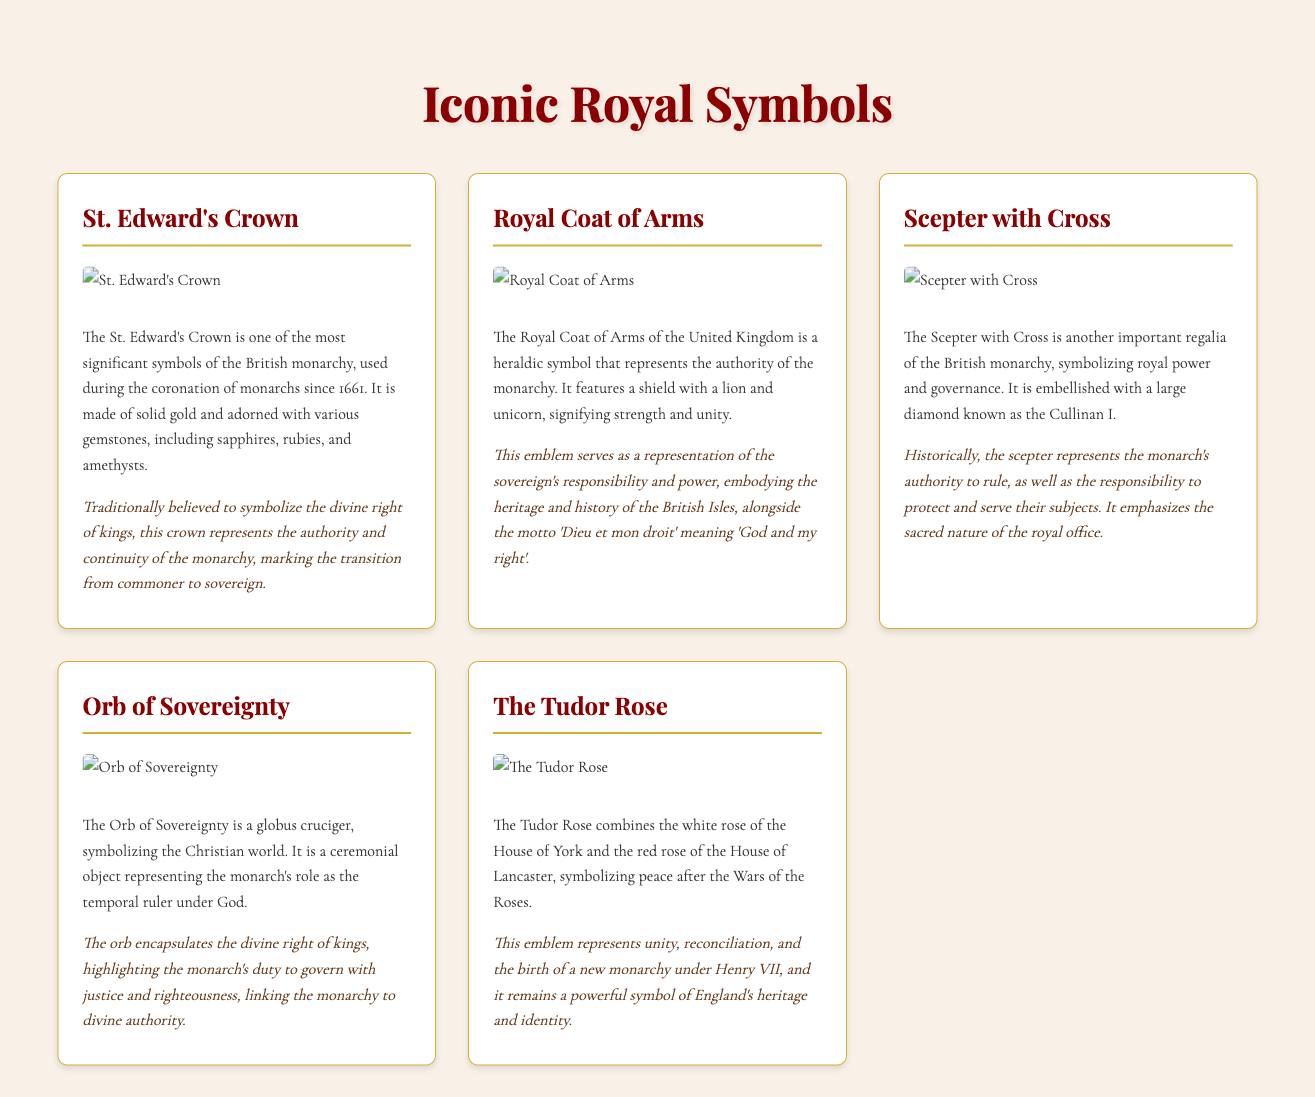What crown is used during the coronation of monarchs since 1661? The document states that the St. Edward's Crown is used during the coronation of monarchs since 1661.
Answer: St. Edward's Crown What animal is featured in the Royal Coat of Arms alongside a unicorn? The Royal Coat of Arms features a lion alongside a unicorn.
Answer: Lion What gemstone is known as Cullinan I? The Cullinan I is known as a large diamond that embellishes the Scepter with Cross.
Answer: Large diamond What does the Orb of Sovereignty symbolize? The Orb of Sovereignty symbolizes the Christian world and the monarch's role as the temporal ruler under God.
Answer: Christian world Which two houses are represented in The Tudor Rose? The Tudor Rose combines the white rose of the House of York and the red rose of the House of Lancaster.
Answer: House of York and House of Lancaster What is the motto associated with the Royal Coat of Arms? The motto associated with the Royal Coat of Arms is 'Dieu et mon droit'.
Answer: Dieu et mon droit Which symbol is traditionally believed to represent the divine right of kings? The St. Edward's Crown is traditionally believed to represent the divine right of kings.
Answer: St. Edward's Crown What does the Scepter with Cross emphasize about the royal office? The Scepter with Cross emphasizes the sacred nature of the royal office.
Answer: Sacred nature How does The Tudor Rose relate to England's heritage? The Tudor Rose remains a powerful symbol of England's heritage and identity.
Answer: Powerful symbol of England's heritage 